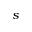Convert formula to latex. <formula><loc_0><loc_0><loc_500><loc_500>s</formula> 